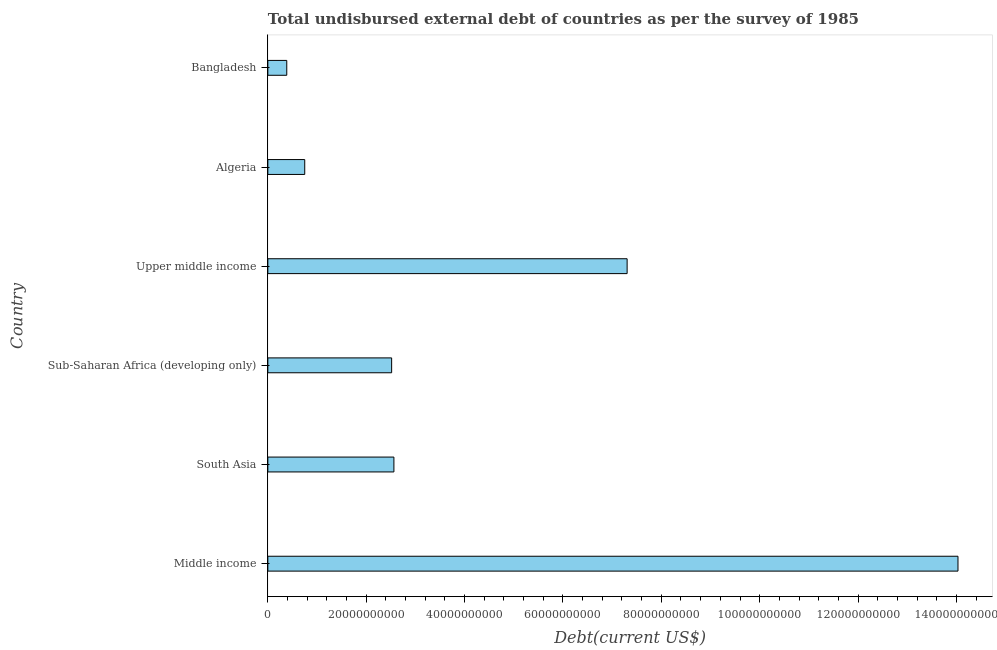Does the graph contain grids?
Offer a very short reply. No. What is the title of the graph?
Provide a succinct answer. Total undisbursed external debt of countries as per the survey of 1985. What is the label or title of the X-axis?
Ensure brevity in your answer.  Debt(current US$). What is the total debt in Sub-Saharan Africa (developing only)?
Keep it short and to the point. 2.52e+1. Across all countries, what is the maximum total debt?
Provide a succinct answer. 1.40e+11. Across all countries, what is the minimum total debt?
Your answer should be very brief. 3.85e+09. In which country was the total debt maximum?
Provide a succinct answer. Middle income. What is the sum of the total debt?
Offer a terse response. 2.76e+11. What is the difference between the total debt in Bangladesh and Upper middle income?
Provide a succinct answer. -6.92e+1. What is the average total debt per country?
Your answer should be very brief. 4.59e+1. What is the median total debt?
Make the answer very short. 2.54e+1. In how many countries, is the total debt greater than 24000000000 US$?
Keep it short and to the point. 4. What is the ratio of the total debt in South Asia to that in Upper middle income?
Offer a very short reply. 0.35. What is the difference between the highest and the second highest total debt?
Your response must be concise. 6.73e+1. What is the difference between the highest and the lowest total debt?
Give a very brief answer. 1.36e+11. How many bars are there?
Provide a succinct answer. 6. What is the Debt(current US$) in Middle income?
Your answer should be compact. 1.40e+11. What is the Debt(current US$) of South Asia?
Make the answer very short. 2.56e+1. What is the Debt(current US$) in Sub-Saharan Africa (developing only)?
Offer a very short reply. 2.52e+1. What is the Debt(current US$) in Upper middle income?
Your answer should be very brief. 7.30e+1. What is the Debt(current US$) of Algeria?
Offer a terse response. 7.50e+09. What is the Debt(current US$) in Bangladesh?
Ensure brevity in your answer.  3.85e+09. What is the difference between the Debt(current US$) in Middle income and South Asia?
Make the answer very short. 1.15e+11. What is the difference between the Debt(current US$) in Middle income and Sub-Saharan Africa (developing only)?
Ensure brevity in your answer.  1.15e+11. What is the difference between the Debt(current US$) in Middle income and Upper middle income?
Provide a short and direct response. 6.73e+1. What is the difference between the Debt(current US$) in Middle income and Algeria?
Offer a very short reply. 1.33e+11. What is the difference between the Debt(current US$) in Middle income and Bangladesh?
Offer a terse response. 1.36e+11. What is the difference between the Debt(current US$) in South Asia and Sub-Saharan Africa (developing only)?
Provide a succinct answer. 4.59e+08. What is the difference between the Debt(current US$) in South Asia and Upper middle income?
Keep it short and to the point. -4.74e+1. What is the difference between the Debt(current US$) in South Asia and Algeria?
Offer a terse response. 1.81e+1. What is the difference between the Debt(current US$) in South Asia and Bangladesh?
Offer a terse response. 2.18e+1. What is the difference between the Debt(current US$) in Sub-Saharan Africa (developing only) and Upper middle income?
Offer a terse response. -4.79e+1. What is the difference between the Debt(current US$) in Sub-Saharan Africa (developing only) and Algeria?
Keep it short and to the point. 1.77e+1. What is the difference between the Debt(current US$) in Sub-Saharan Africa (developing only) and Bangladesh?
Offer a very short reply. 2.13e+1. What is the difference between the Debt(current US$) in Upper middle income and Algeria?
Your response must be concise. 6.55e+1. What is the difference between the Debt(current US$) in Upper middle income and Bangladesh?
Your answer should be very brief. 6.92e+1. What is the difference between the Debt(current US$) in Algeria and Bangladesh?
Your answer should be very brief. 3.65e+09. What is the ratio of the Debt(current US$) in Middle income to that in South Asia?
Your answer should be very brief. 5.47. What is the ratio of the Debt(current US$) in Middle income to that in Sub-Saharan Africa (developing only)?
Offer a very short reply. 5.58. What is the ratio of the Debt(current US$) in Middle income to that in Upper middle income?
Offer a very short reply. 1.92. What is the ratio of the Debt(current US$) in Middle income to that in Algeria?
Make the answer very short. 18.71. What is the ratio of the Debt(current US$) in Middle income to that in Bangladesh?
Provide a succinct answer. 36.49. What is the ratio of the Debt(current US$) in South Asia to that in Sub-Saharan Africa (developing only)?
Ensure brevity in your answer.  1.02. What is the ratio of the Debt(current US$) in South Asia to that in Upper middle income?
Your answer should be compact. 0.35. What is the ratio of the Debt(current US$) in South Asia to that in Algeria?
Give a very brief answer. 3.42. What is the ratio of the Debt(current US$) in South Asia to that in Bangladesh?
Make the answer very short. 6.67. What is the ratio of the Debt(current US$) in Sub-Saharan Africa (developing only) to that in Upper middle income?
Make the answer very short. 0.34. What is the ratio of the Debt(current US$) in Sub-Saharan Africa (developing only) to that in Algeria?
Your response must be concise. 3.36. What is the ratio of the Debt(current US$) in Sub-Saharan Africa (developing only) to that in Bangladesh?
Your response must be concise. 6.54. What is the ratio of the Debt(current US$) in Upper middle income to that in Algeria?
Offer a very short reply. 9.74. What is the ratio of the Debt(current US$) in Upper middle income to that in Bangladesh?
Offer a very short reply. 19. What is the ratio of the Debt(current US$) in Algeria to that in Bangladesh?
Offer a terse response. 1.95. 